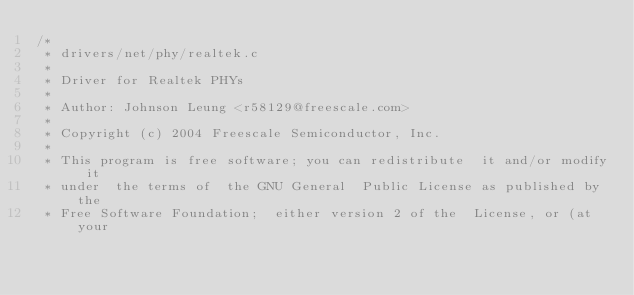<code> <loc_0><loc_0><loc_500><loc_500><_C_>/*
 * drivers/net/phy/realtek.c
 *
 * Driver for Realtek PHYs
 *
 * Author: Johnson Leung <r58129@freescale.com>
 *
 * Copyright (c) 2004 Freescale Semiconductor, Inc.
 *
 * This program is free software; you can redistribute  it and/or modify it
 * under  the terms of  the GNU General  Public License as published by the
 * Free Software Foundation;  either version 2 of the  License, or (at your</code> 